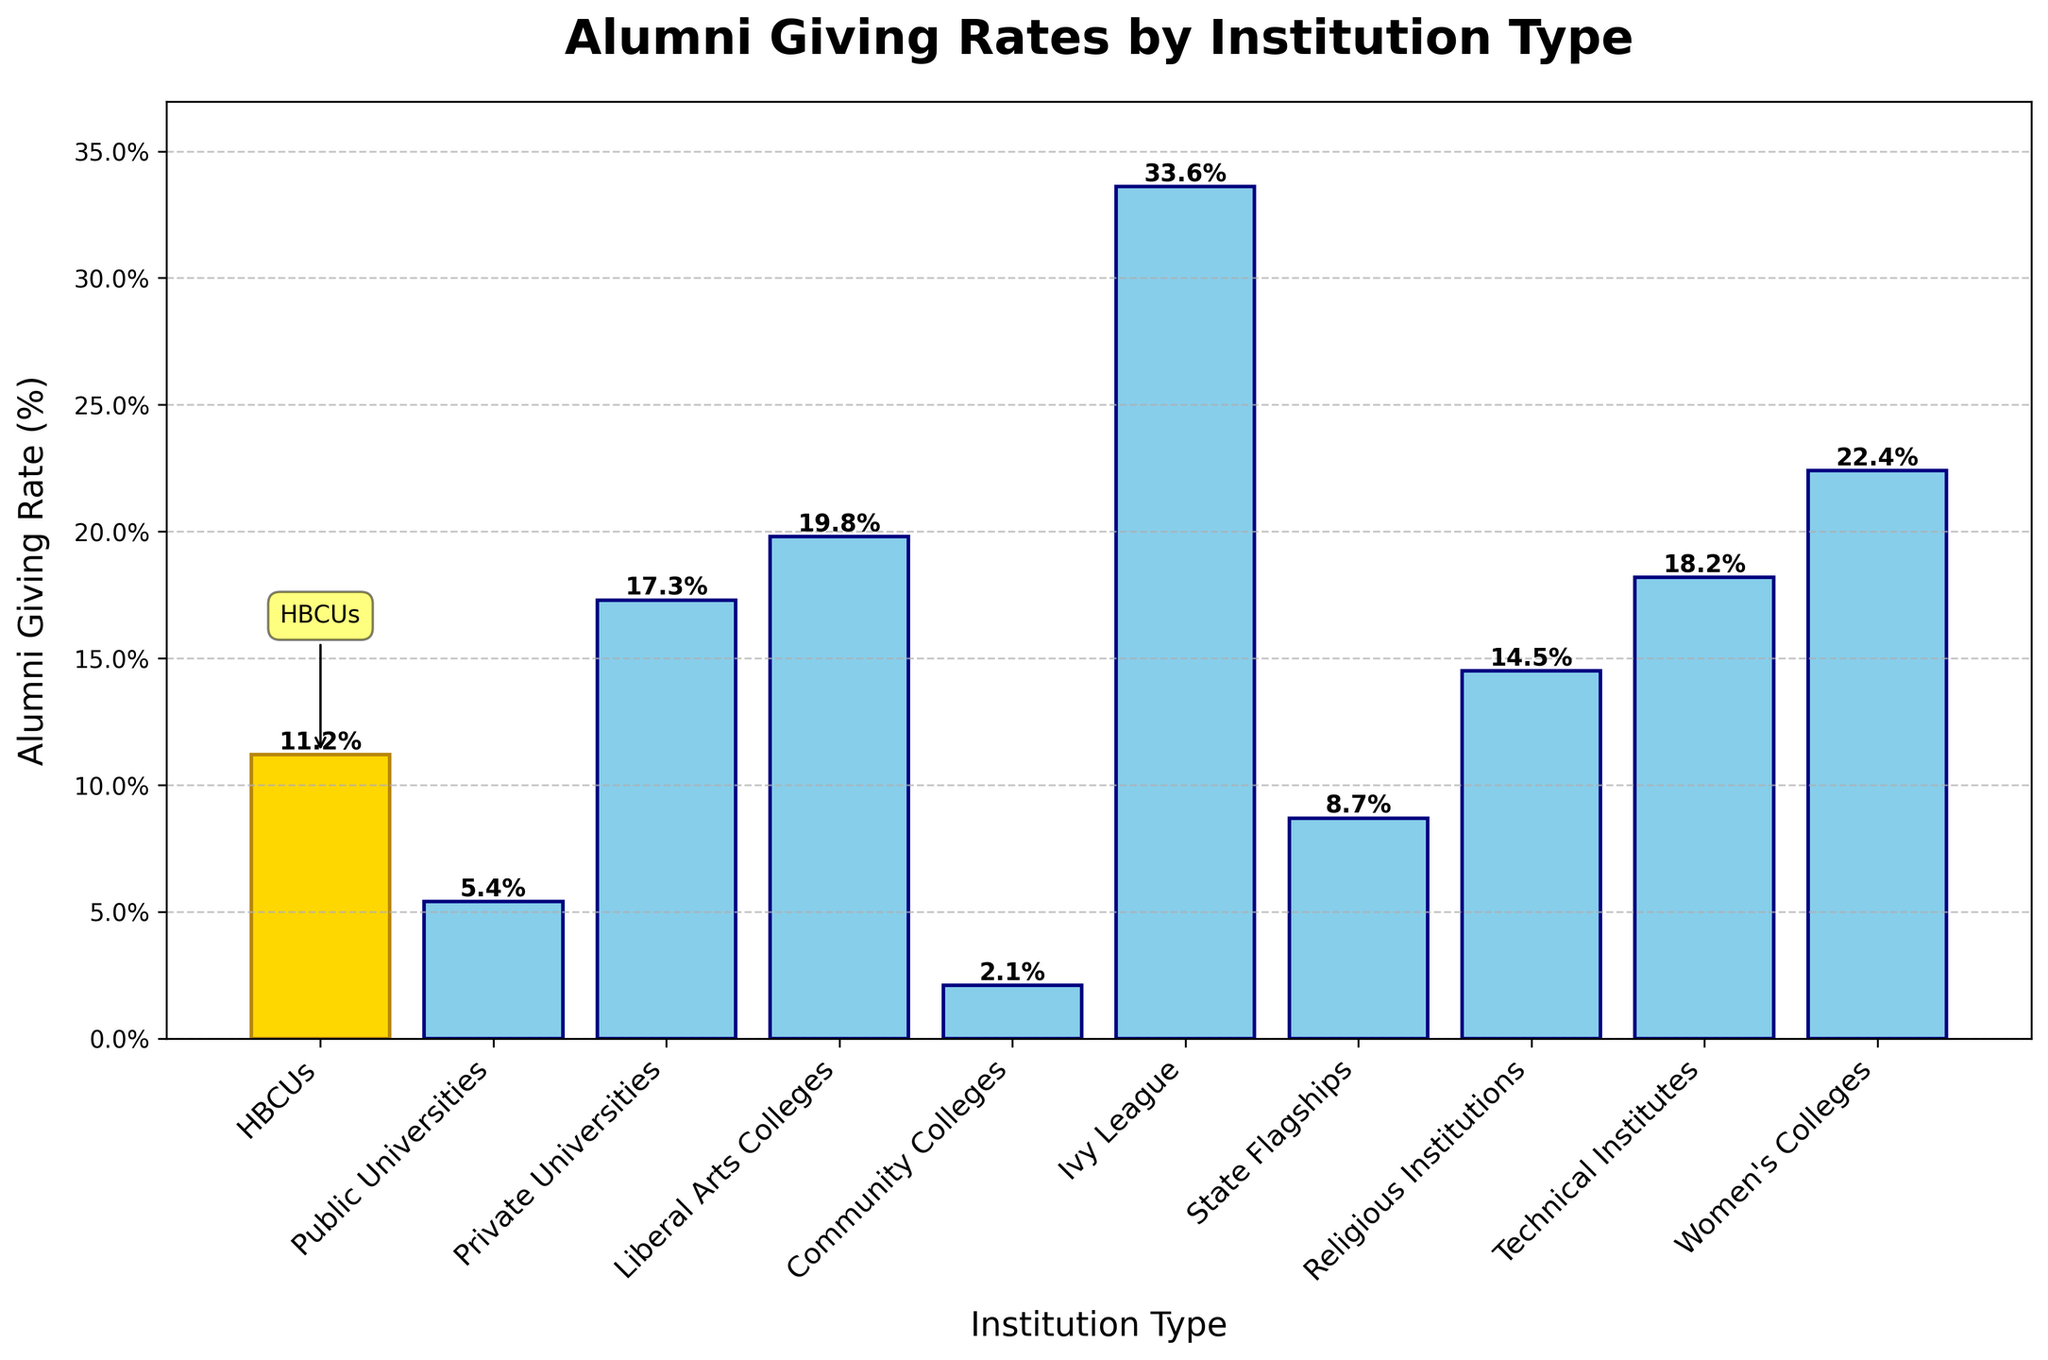What is the alumni giving rate for HBCUs? The bar labeled "HBCUs" shows a height corresponding to an alumni giving rate of 11.2%. This value is also annotated directly on top of the bar.
Answer: 11.2% Which institution type has the highest alumni giving rate? By comparing the heights of all the bars, the "Ivy League" institutions have the tallest bar, indicating the highest alumni giving rate of 33.6%.
Answer: Ivy League How much higher is the alumni giving rate for Ivy League institutions compared to HBCUs? The giving rate for Ivy League institutions is 33.6%, and for HBCUs it is 11.2%. The difference is calculated as 33.6% - 11.2% = 22.4%.
Answer: 22.4% Which two institution types have giving rates closest to HBCUs? By visually comparing the bars around the HBCUs bar, "State Flagships" and "Public Universities" have giving rates of 8.7% and 5.4% respectively, which are the closest values to 11.2%.
Answer: State Flagships and Public Universities What is the total alumni giving rate for Public Universities, Private Universities, and Community Colleges combined? Summing the giving rates of these institutions: 5.4% (Public Universities) + 17.3% (Private Universities) + 2.1% (Community Colleges) = 24.8%.
Answer: 24.8% Is the alumni giving rate for Technical Institutes greater than that for Women's Colleges? Comparing the bars for Technical Institutes (18.2%) and Women's Colleges (22.4%), the bar for Women's Colleges is taller, showing a higher giving rate.
Answer: No What visual feature distinguishes the HBCUs bar from others? The HBCUs bar is colored gold with a dark goldenrod edge, and has an arrow and box annotation labeling it as "HBCUs."
Answer: It is colored gold with additional annotations How does the average giving rate of Private Universities and Liberal Arts Colleges compare to the giving rate of Technical Institutes? The average giving rate for Private Universities and Liberal Arts Colleges is (17.3% + 19.8%) / 2 = 18.55%, which is slightly higher than the 18.2% for Technical Institutes.
Answer: Slightly higher By what factor is the giving rate of Ivy League institutions larger than that of Community Colleges? The giving rate for Ivy League institutions is 33.6%, and for Community Colleges, it is 2.1%. The factor is calculated as 33.6 / 2.1 ≈ 16.
Answer: Approximately 16 times 